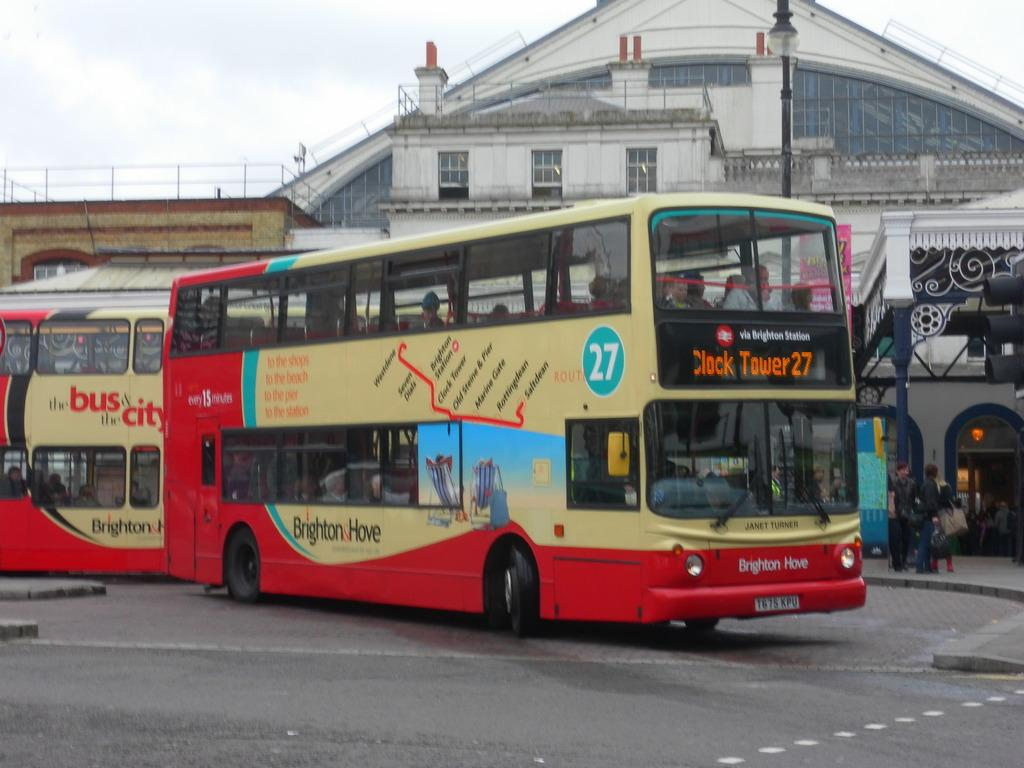Provide a one-sentence caption for the provided image. A bus via Brighton Station displays a sign for Clock tower 27. 